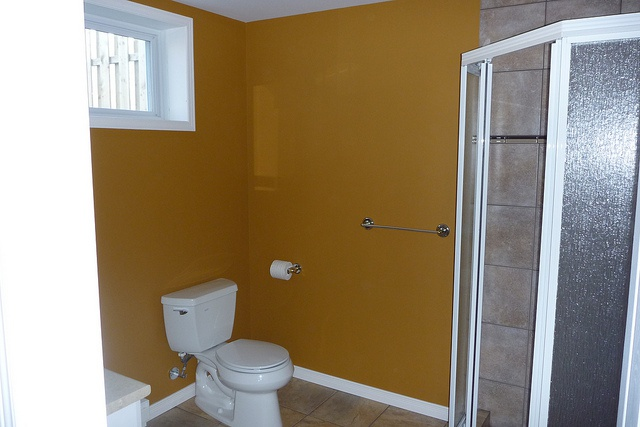Describe the objects in this image and their specific colors. I can see a toilet in white, darkgray, and gray tones in this image. 